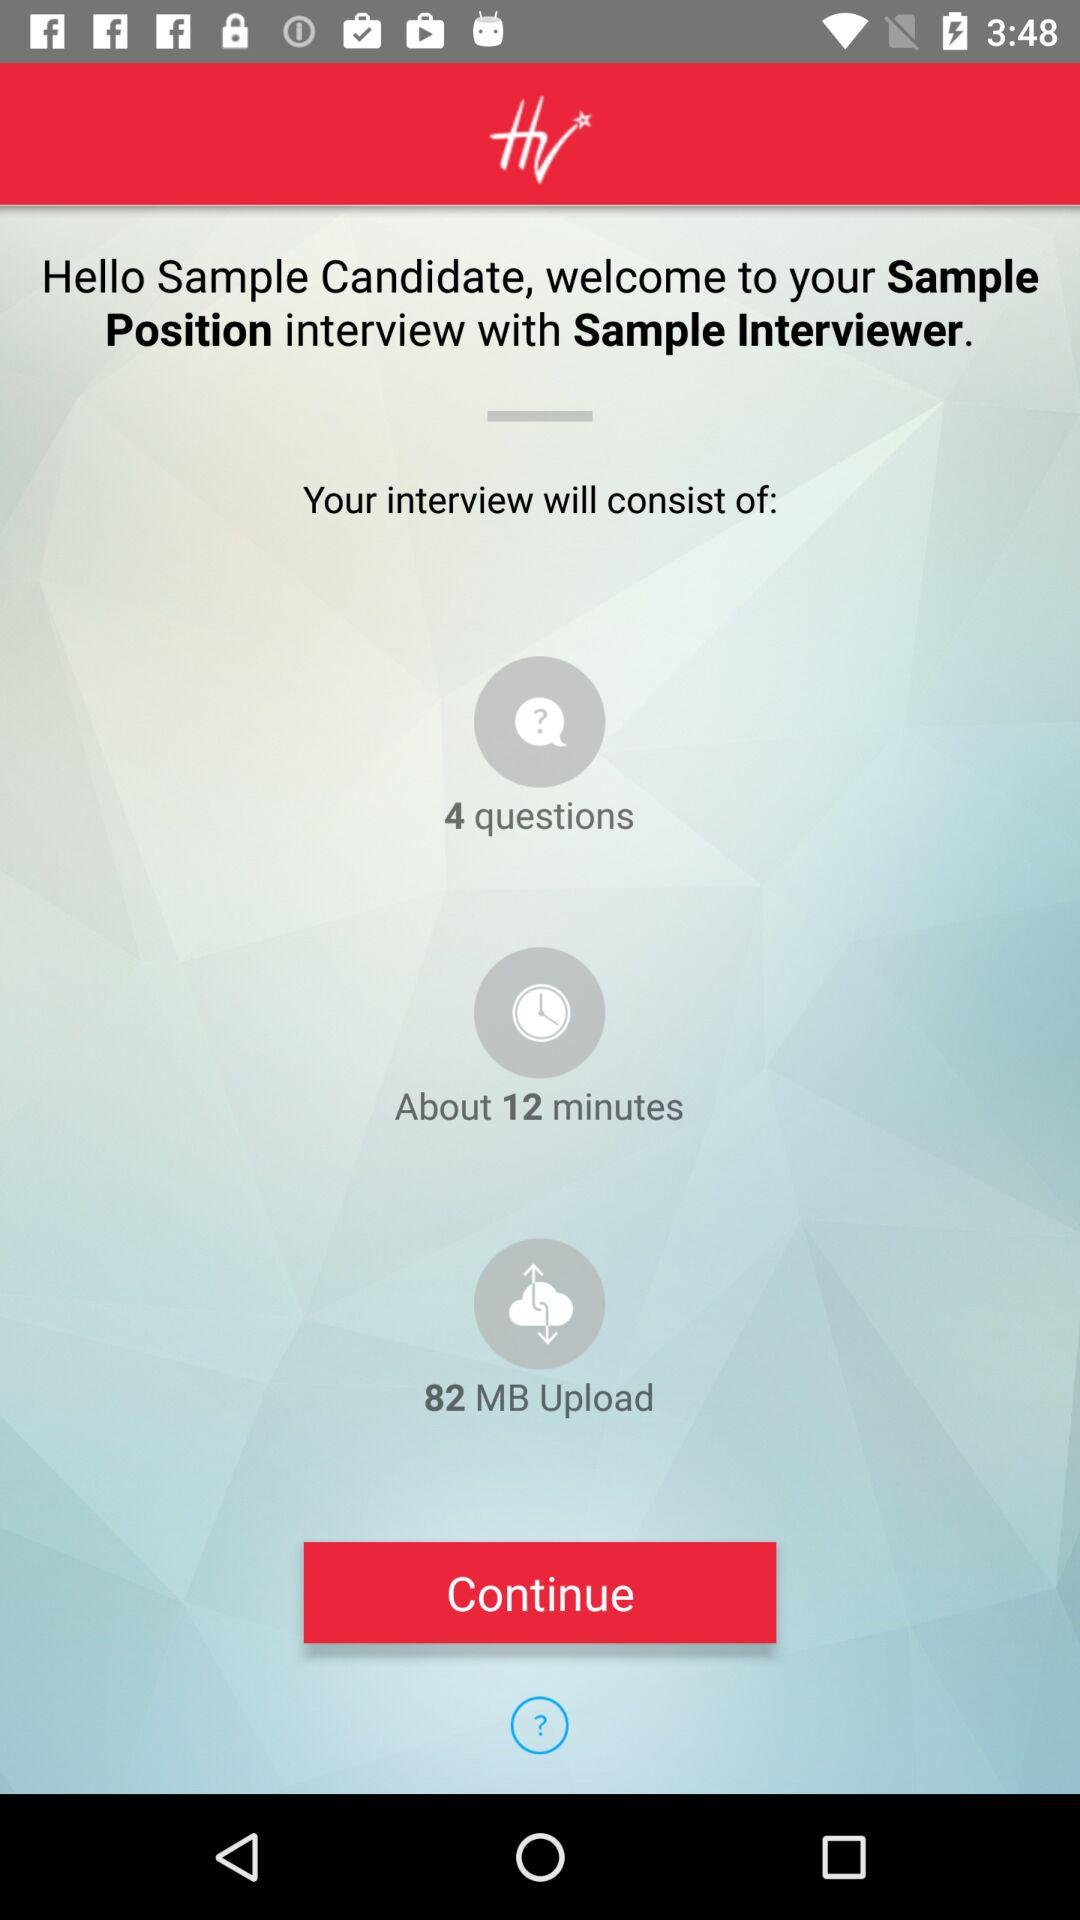How many more minutes than questions will the interview take?
Answer the question using a single word or phrase. 8 